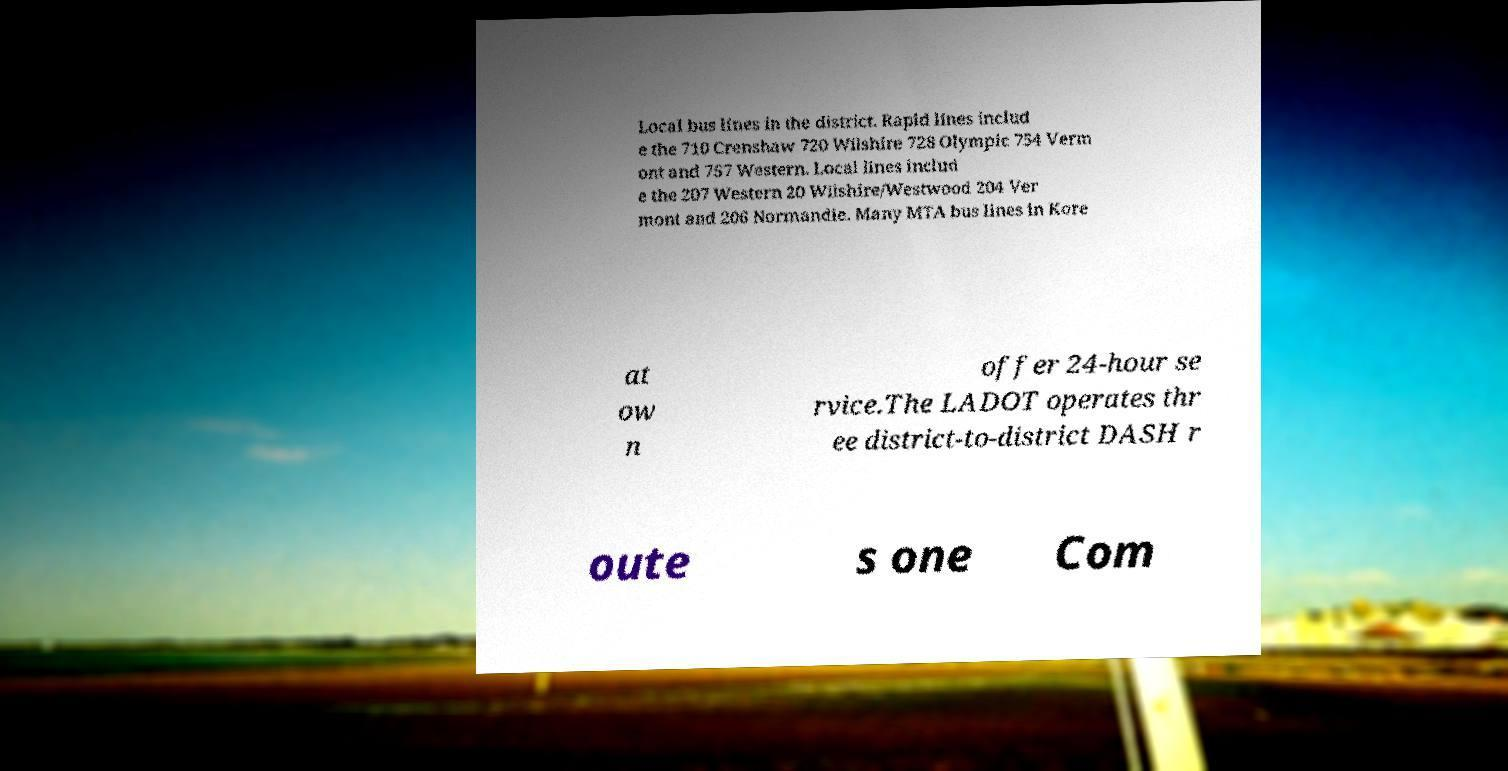Could you extract and type out the text from this image? Local bus lines in the district. Rapid lines includ e the 710 Crenshaw 720 Wilshire 728 Olympic 754 Verm ont and 757 Western. Local lines includ e the 207 Western 20 Wilshire/Westwood 204 Ver mont and 206 Normandie. Many MTA bus lines in Kore at ow n offer 24-hour se rvice.The LADOT operates thr ee district-to-district DASH r oute s one Com 